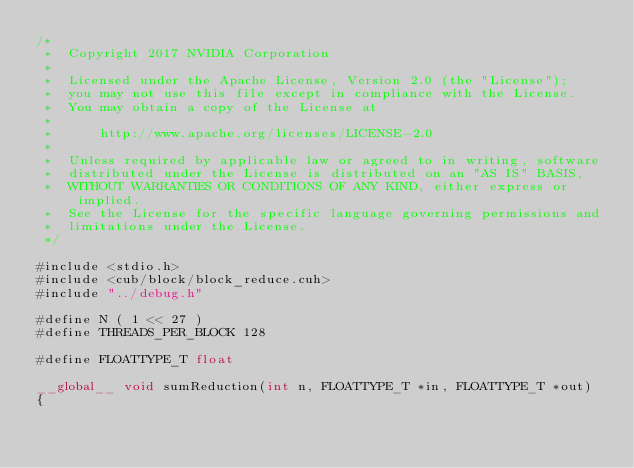Convert code to text. <code><loc_0><loc_0><loc_500><loc_500><_Cuda_>/*
 *  Copyright 2017 NVIDIA Corporation
 *
 *  Licensed under the Apache License, Version 2.0 (the "License");
 *  you may not use this file except in compliance with the License.
 *  You may obtain a copy of the License at
 *
 *      http://www.apache.org/licenses/LICENSE-2.0
 *
 *  Unless required by applicable law or agreed to in writing, software
 *  distributed under the License is distributed on an "AS IS" BASIS,
 *  WITHOUT WARRANTIES OR CONDITIONS OF ANY KIND, either express or implied.
 *  See the License for the specific language governing permissions and
 *  limitations under the License.
 */

#include <stdio.h>
#include <cub/block/block_reduce.cuh>
#include "../debug.h"

#define N ( 1 << 27 )
#define THREADS_PER_BLOCK 128

#define FLOATTYPE_T float

__global__ void sumReduction(int n, FLOATTYPE_T *in, FLOATTYPE_T *out)
{
</code> 